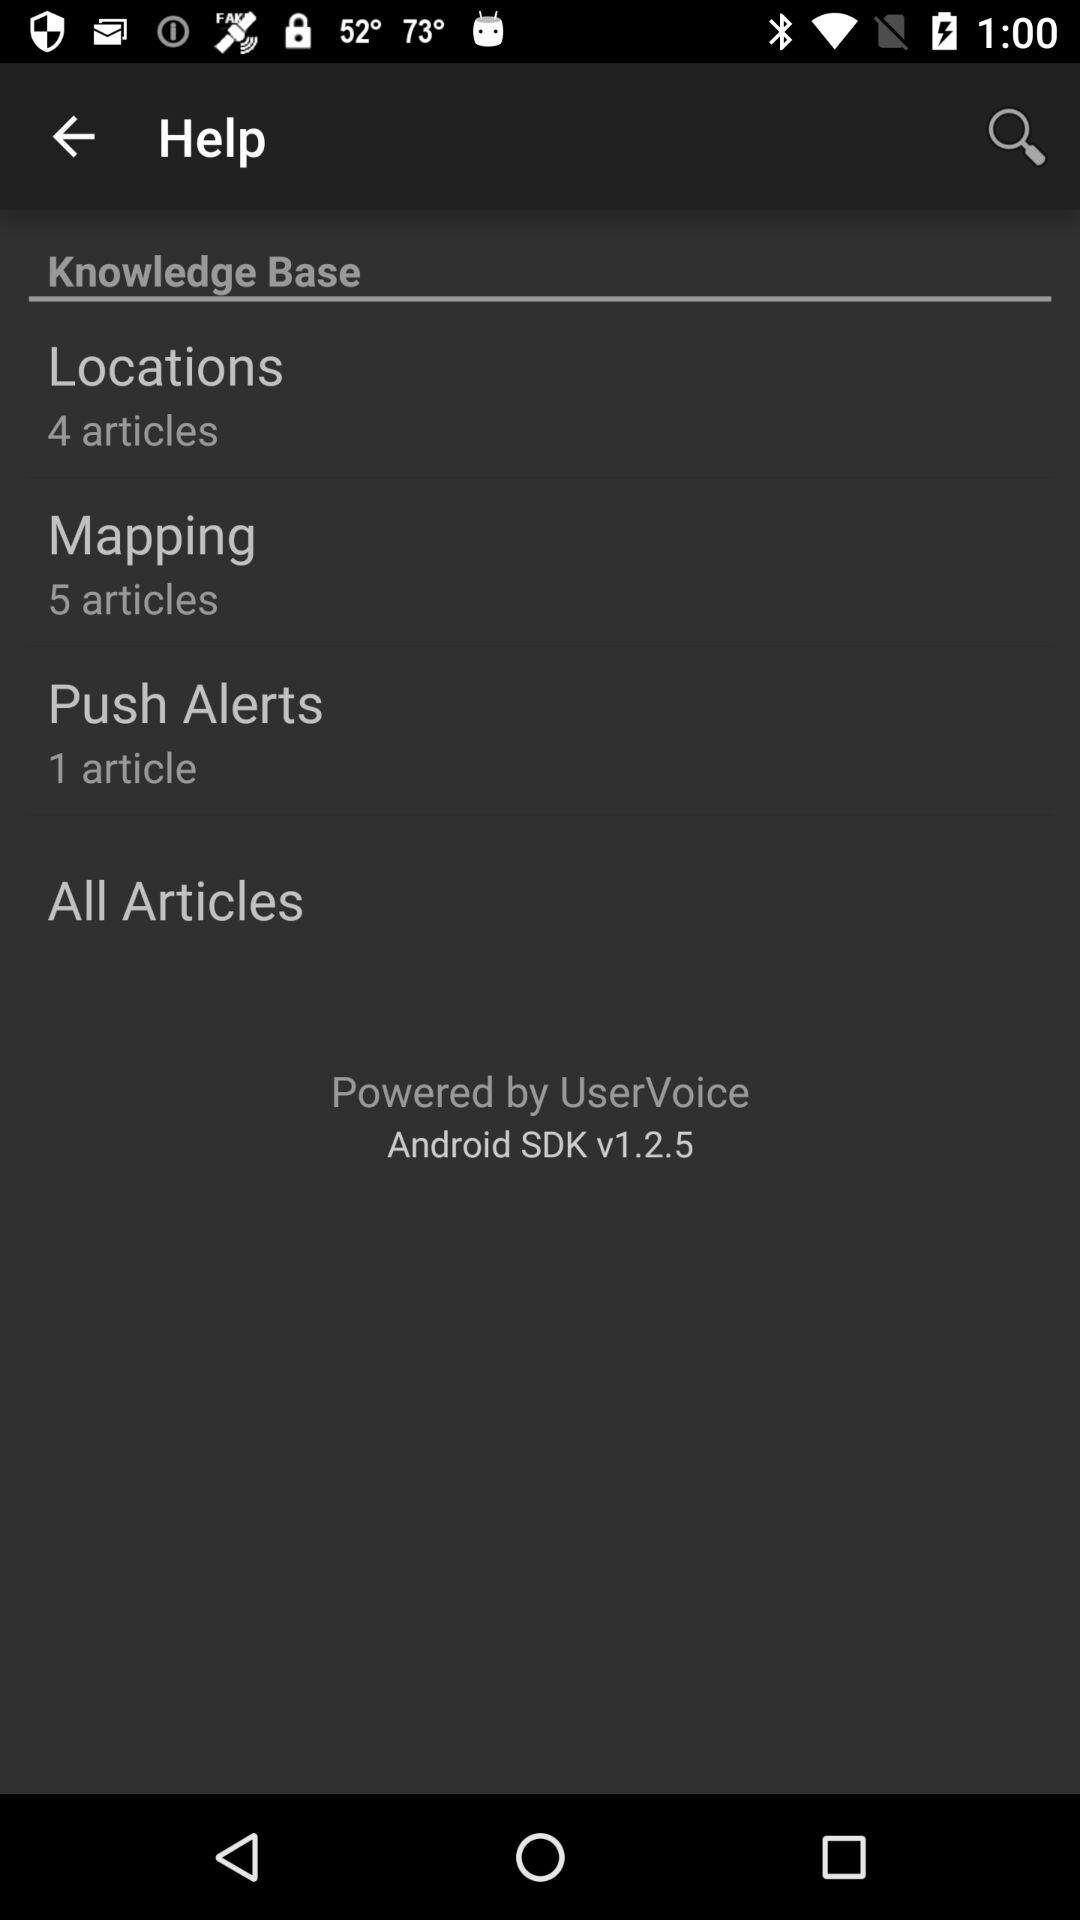How many articles are there in "Locations"? There are four articles in "Locations". 